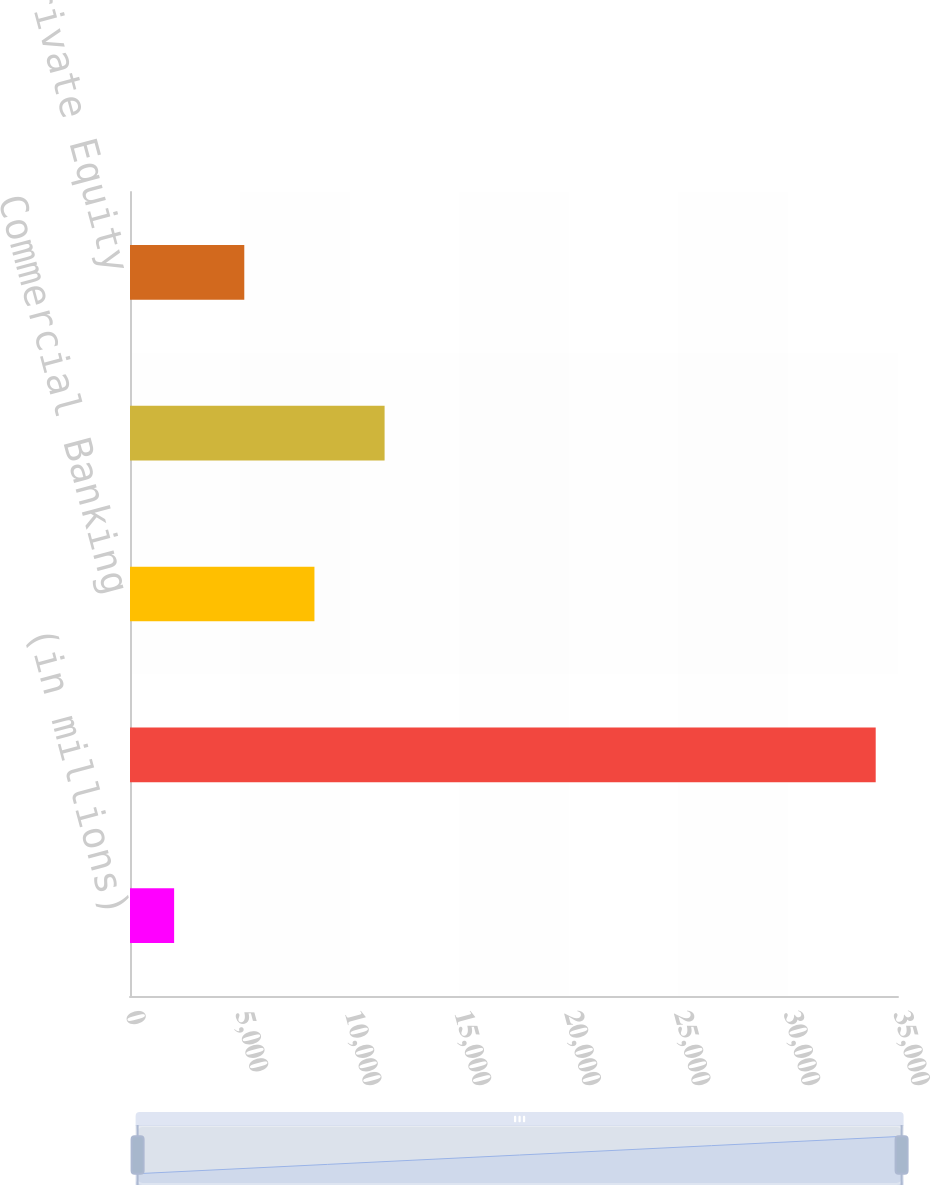<chart> <loc_0><loc_0><loc_500><loc_500><bar_chart><fcel>(in millions)<fcel>Corporate & Investment Bank<fcel>Commercial Banking<fcel>Asset Management<fcel>Corporate/Private Equity<nl><fcel>2011<fcel>33984<fcel>8405.6<fcel>11602.9<fcel>5208.3<nl></chart> 